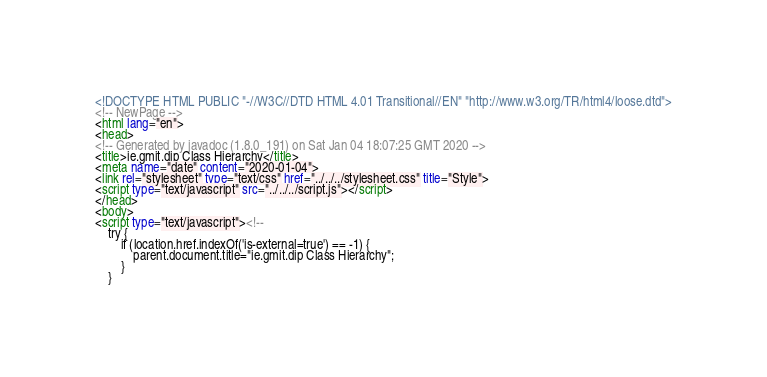Convert code to text. <code><loc_0><loc_0><loc_500><loc_500><_HTML_><!DOCTYPE HTML PUBLIC "-//W3C//DTD HTML 4.01 Transitional//EN" "http://www.w3.org/TR/html4/loose.dtd">
<!-- NewPage -->
<html lang="en">
<head>
<!-- Generated by javadoc (1.8.0_191) on Sat Jan 04 18:07:25 GMT 2020 -->
<title>ie.gmit.dip Class Hierarchy</title>
<meta name="date" content="2020-01-04">
<link rel="stylesheet" type="text/css" href="../../../stylesheet.css" title="Style">
<script type="text/javascript" src="../../../script.js"></script>
</head>
<body>
<script type="text/javascript"><!--
    try {
        if (location.href.indexOf('is-external=true') == -1) {
            parent.document.title="ie.gmit.dip Class Hierarchy";
        }
    }</code> 